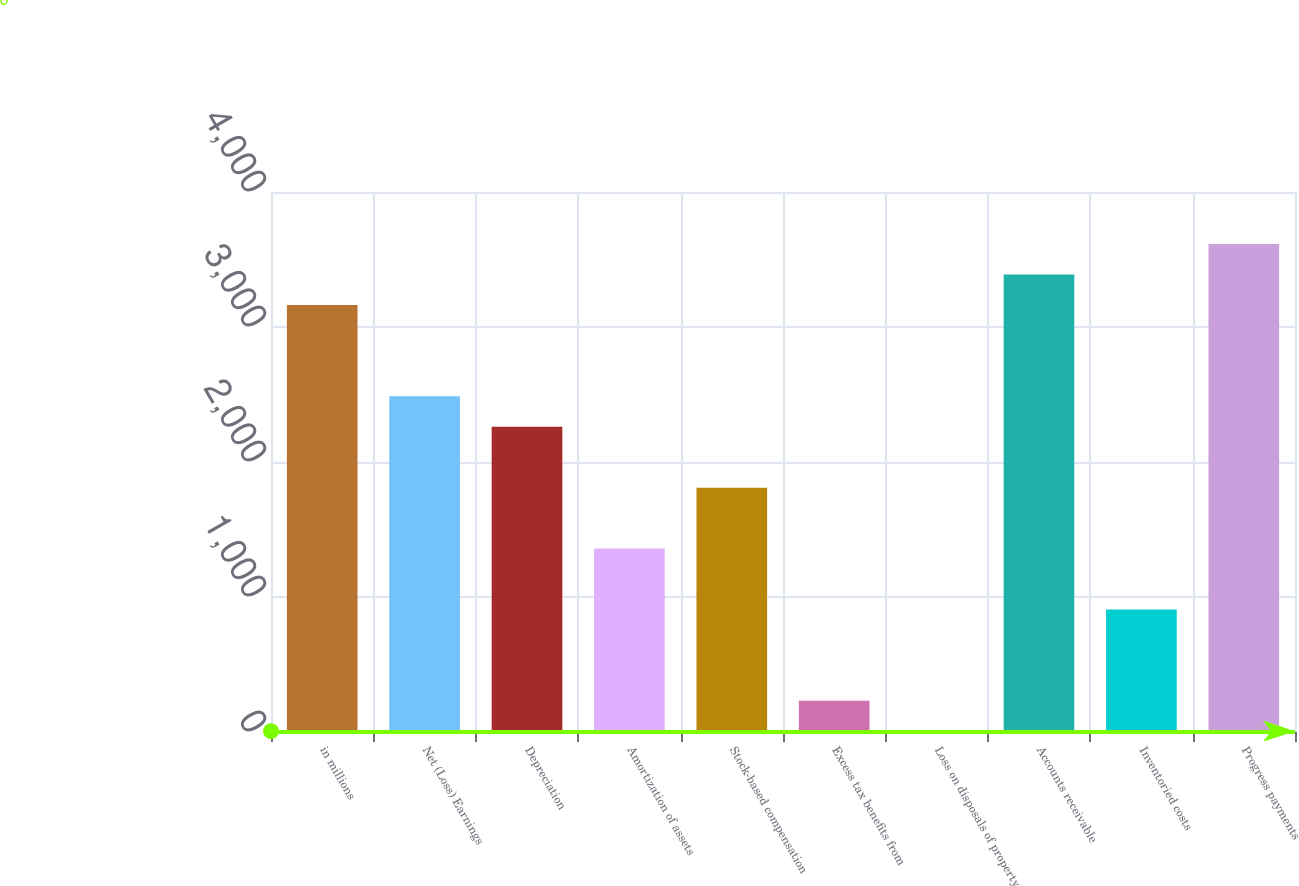Convert chart. <chart><loc_0><loc_0><loc_500><loc_500><bar_chart><fcel>in millions<fcel>Net (Loss) Earnings<fcel>Depreciation<fcel>Amortization of assets<fcel>Stock-based compensation<fcel>Excess tax benefits from<fcel>Loss on disposals of property<fcel>Accounts receivable<fcel>Inventoried costs<fcel>Progress payments<nl><fcel>3163<fcel>2486.5<fcel>2261<fcel>1359<fcel>1810<fcel>231.5<fcel>6<fcel>3388.5<fcel>908<fcel>3614<nl></chart> 